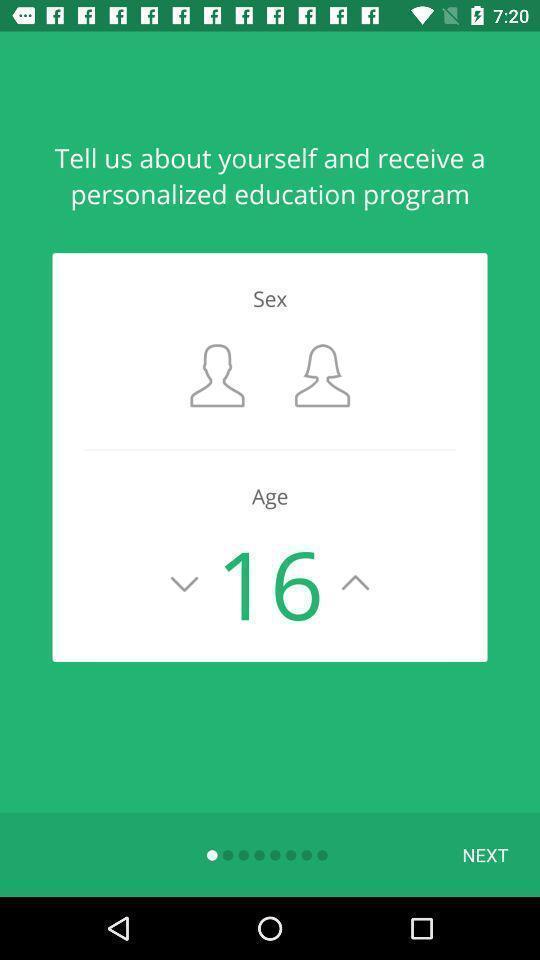What is the overall content of this screenshot? Starting page for the learning app. 